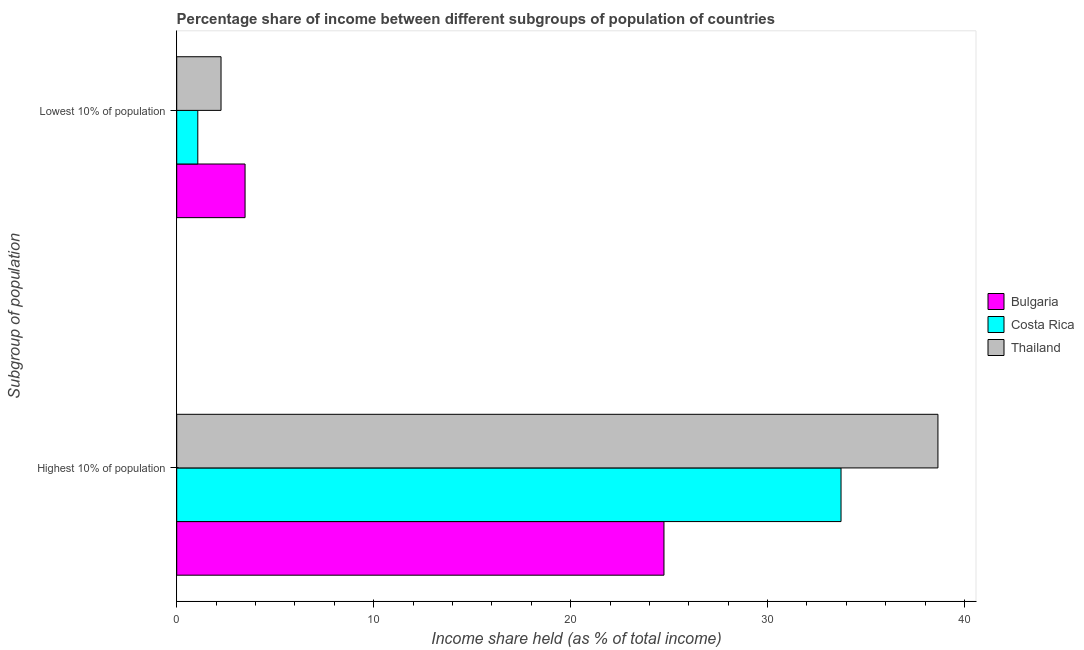Are the number of bars per tick equal to the number of legend labels?
Give a very brief answer. Yes. Are the number of bars on each tick of the Y-axis equal?
Your response must be concise. Yes. How many bars are there on the 2nd tick from the top?
Your answer should be very brief. 3. How many bars are there on the 2nd tick from the bottom?
Keep it short and to the point. 3. What is the label of the 1st group of bars from the top?
Your answer should be very brief. Lowest 10% of population. What is the income share held by highest 10% of the population in Thailand?
Ensure brevity in your answer.  38.65. Across all countries, what is the maximum income share held by highest 10% of the population?
Keep it short and to the point. 38.65. Across all countries, what is the minimum income share held by highest 10% of the population?
Offer a very short reply. 24.74. In which country was the income share held by lowest 10% of the population maximum?
Keep it short and to the point. Bulgaria. In which country was the income share held by lowest 10% of the population minimum?
Your answer should be compact. Costa Rica. What is the total income share held by lowest 10% of the population in the graph?
Your answer should be very brief. 6.79. What is the difference between the income share held by highest 10% of the population in Costa Rica and that in Bulgaria?
Provide a succinct answer. 8.99. What is the difference between the income share held by highest 10% of the population in Thailand and the income share held by lowest 10% of the population in Bulgaria?
Make the answer very short. 35.18. What is the average income share held by lowest 10% of the population per country?
Your response must be concise. 2.26. What is the difference between the income share held by lowest 10% of the population and income share held by highest 10% of the population in Costa Rica?
Provide a succinct answer. -32.66. What is the ratio of the income share held by highest 10% of the population in Bulgaria to that in Costa Rica?
Offer a very short reply. 0.73. Is the income share held by lowest 10% of the population in Thailand less than that in Bulgaria?
Offer a very short reply. Yes. In how many countries, is the income share held by lowest 10% of the population greater than the average income share held by lowest 10% of the population taken over all countries?
Your answer should be compact. 1. What does the 1st bar from the top in Lowest 10% of population represents?
Your answer should be compact. Thailand. How many countries are there in the graph?
Give a very brief answer. 3. What is the difference between two consecutive major ticks on the X-axis?
Provide a short and direct response. 10. Are the values on the major ticks of X-axis written in scientific E-notation?
Your response must be concise. No. Does the graph contain any zero values?
Provide a short and direct response. No. How many legend labels are there?
Your answer should be very brief. 3. How are the legend labels stacked?
Make the answer very short. Vertical. What is the title of the graph?
Offer a very short reply. Percentage share of income between different subgroups of population of countries. Does "Bermuda" appear as one of the legend labels in the graph?
Your answer should be very brief. No. What is the label or title of the X-axis?
Keep it short and to the point. Income share held (as % of total income). What is the label or title of the Y-axis?
Make the answer very short. Subgroup of population. What is the Income share held (as % of total income) in Bulgaria in Highest 10% of population?
Offer a terse response. 24.74. What is the Income share held (as % of total income) in Costa Rica in Highest 10% of population?
Ensure brevity in your answer.  33.73. What is the Income share held (as % of total income) of Thailand in Highest 10% of population?
Keep it short and to the point. 38.65. What is the Income share held (as % of total income) in Bulgaria in Lowest 10% of population?
Keep it short and to the point. 3.47. What is the Income share held (as % of total income) of Costa Rica in Lowest 10% of population?
Provide a short and direct response. 1.07. What is the Income share held (as % of total income) of Thailand in Lowest 10% of population?
Offer a terse response. 2.25. Across all Subgroup of population, what is the maximum Income share held (as % of total income) of Bulgaria?
Ensure brevity in your answer.  24.74. Across all Subgroup of population, what is the maximum Income share held (as % of total income) in Costa Rica?
Offer a terse response. 33.73. Across all Subgroup of population, what is the maximum Income share held (as % of total income) in Thailand?
Keep it short and to the point. 38.65. Across all Subgroup of population, what is the minimum Income share held (as % of total income) of Bulgaria?
Provide a succinct answer. 3.47. Across all Subgroup of population, what is the minimum Income share held (as % of total income) in Costa Rica?
Give a very brief answer. 1.07. Across all Subgroup of population, what is the minimum Income share held (as % of total income) of Thailand?
Provide a succinct answer. 2.25. What is the total Income share held (as % of total income) in Bulgaria in the graph?
Provide a short and direct response. 28.21. What is the total Income share held (as % of total income) of Costa Rica in the graph?
Offer a terse response. 34.8. What is the total Income share held (as % of total income) in Thailand in the graph?
Your answer should be very brief. 40.9. What is the difference between the Income share held (as % of total income) in Bulgaria in Highest 10% of population and that in Lowest 10% of population?
Keep it short and to the point. 21.27. What is the difference between the Income share held (as % of total income) of Costa Rica in Highest 10% of population and that in Lowest 10% of population?
Provide a short and direct response. 32.66. What is the difference between the Income share held (as % of total income) of Thailand in Highest 10% of population and that in Lowest 10% of population?
Offer a terse response. 36.4. What is the difference between the Income share held (as % of total income) of Bulgaria in Highest 10% of population and the Income share held (as % of total income) of Costa Rica in Lowest 10% of population?
Keep it short and to the point. 23.67. What is the difference between the Income share held (as % of total income) in Bulgaria in Highest 10% of population and the Income share held (as % of total income) in Thailand in Lowest 10% of population?
Your answer should be very brief. 22.49. What is the difference between the Income share held (as % of total income) of Costa Rica in Highest 10% of population and the Income share held (as % of total income) of Thailand in Lowest 10% of population?
Provide a succinct answer. 31.48. What is the average Income share held (as % of total income) in Bulgaria per Subgroup of population?
Your answer should be very brief. 14.11. What is the average Income share held (as % of total income) in Costa Rica per Subgroup of population?
Make the answer very short. 17.4. What is the average Income share held (as % of total income) in Thailand per Subgroup of population?
Your answer should be compact. 20.45. What is the difference between the Income share held (as % of total income) of Bulgaria and Income share held (as % of total income) of Costa Rica in Highest 10% of population?
Offer a very short reply. -8.99. What is the difference between the Income share held (as % of total income) in Bulgaria and Income share held (as % of total income) in Thailand in Highest 10% of population?
Ensure brevity in your answer.  -13.91. What is the difference between the Income share held (as % of total income) in Costa Rica and Income share held (as % of total income) in Thailand in Highest 10% of population?
Your answer should be very brief. -4.92. What is the difference between the Income share held (as % of total income) in Bulgaria and Income share held (as % of total income) in Thailand in Lowest 10% of population?
Your response must be concise. 1.22. What is the difference between the Income share held (as % of total income) in Costa Rica and Income share held (as % of total income) in Thailand in Lowest 10% of population?
Offer a very short reply. -1.18. What is the ratio of the Income share held (as % of total income) of Bulgaria in Highest 10% of population to that in Lowest 10% of population?
Ensure brevity in your answer.  7.13. What is the ratio of the Income share held (as % of total income) of Costa Rica in Highest 10% of population to that in Lowest 10% of population?
Offer a terse response. 31.52. What is the ratio of the Income share held (as % of total income) of Thailand in Highest 10% of population to that in Lowest 10% of population?
Provide a succinct answer. 17.18. What is the difference between the highest and the second highest Income share held (as % of total income) of Bulgaria?
Keep it short and to the point. 21.27. What is the difference between the highest and the second highest Income share held (as % of total income) of Costa Rica?
Give a very brief answer. 32.66. What is the difference between the highest and the second highest Income share held (as % of total income) of Thailand?
Provide a short and direct response. 36.4. What is the difference between the highest and the lowest Income share held (as % of total income) of Bulgaria?
Give a very brief answer. 21.27. What is the difference between the highest and the lowest Income share held (as % of total income) in Costa Rica?
Your response must be concise. 32.66. What is the difference between the highest and the lowest Income share held (as % of total income) of Thailand?
Your response must be concise. 36.4. 